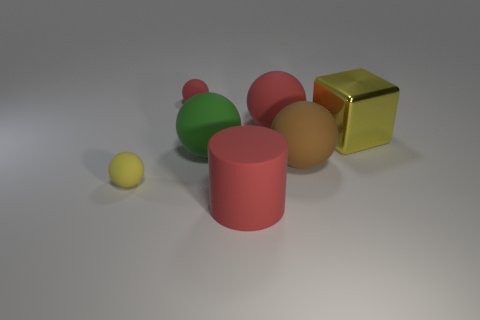Subtract all green rubber balls. How many balls are left? 4 Subtract 4 spheres. How many spheres are left? 1 Add 1 big brown shiny things. How many objects exist? 8 Subtract all red balls. How many balls are left? 3 Subtract all tiny metallic things. Subtract all large yellow cubes. How many objects are left? 6 Add 6 yellow things. How many yellow things are left? 8 Add 7 red matte things. How many red matte things exist? 10 Subtract 1 red balls. How many objects are left? 6 Subtract all balls. How many objects are left? 2 Subtract all cyan blocks. Subtract all gray spheres. How many blocks are left? 1 